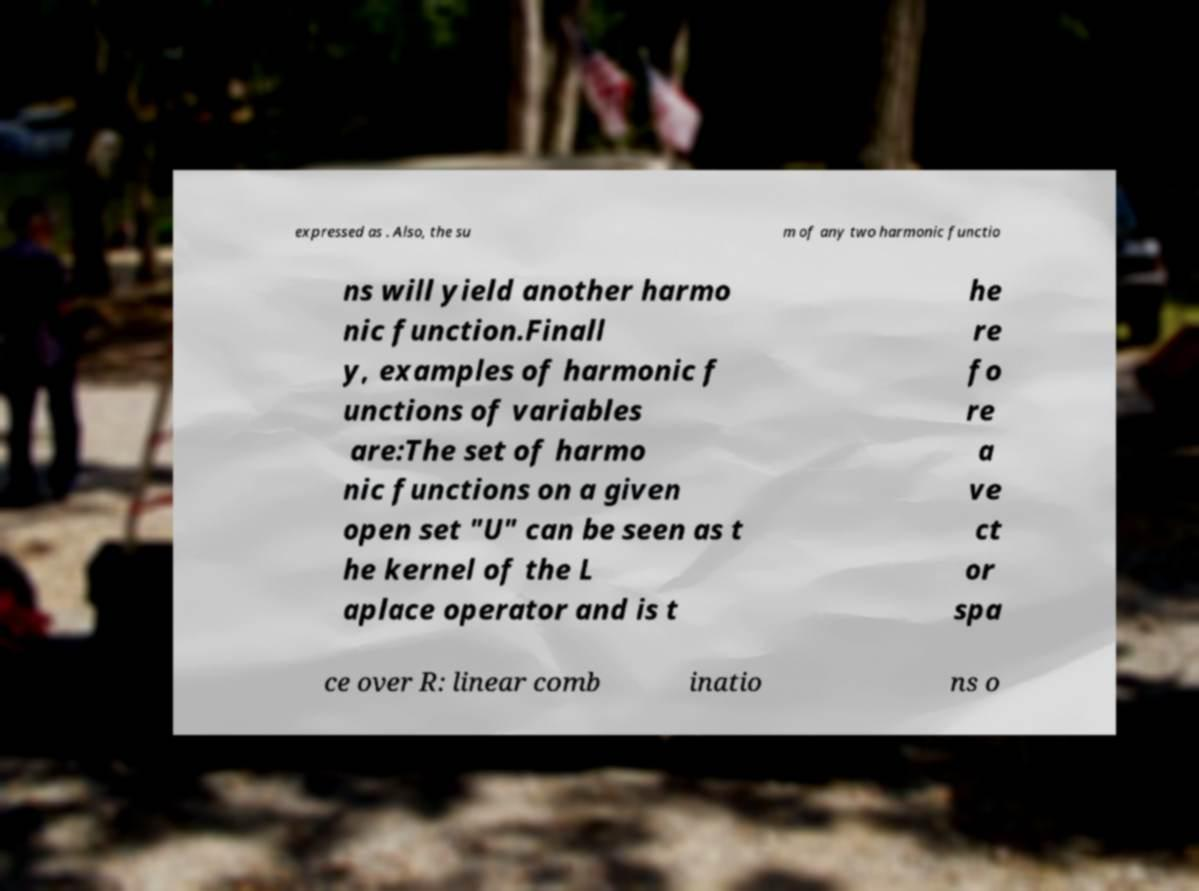Could you assist in decoding the text presented in this image and type it out clearly? expressed as . Also, the su m of any two harmonic functio ns will yield another harmo nic function.Finall y, examples of harmonic f unctions of variables are:The set of harmo nic functions on a given open set "U" can be seen as t he kernel of the L aplace operator and is t he re fo re a ve ct or spa ce over R: linear comb inatio ns o 